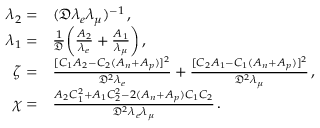Convert formula to latex. <formula><loc_0><loc_0><loc_500><loc_500>\begin{array} { r l } { \lambda _ { 2 } = } & { ( \mathfrak { D } \lambda _ { e } \lambda _ { \mu } ) ^ { - 1 } \, , } \\ { \lambda _ { 1 } = } & { \frac { 1 } { \mathfrak { D } } \left ( \frac { A _ { 2 } } { \lambda _ { e } } + \frac { A _ { 1 } } { \lambda _ { \mu } } \right ) \, , } \\ { \zeta = } & { \frac { [ C _ { 1 } A _ { 2 } - C _ { 2 } ( A _ { n } + A _ { p } ) ] ^ { 2 } } { \mathfrak { D } ^ { 2 } \lambda _ { e } } + \frac { [ C _ { 2 } A _ { 1 } - C _ { 1 } ( A _ { n } + A _ { p } ) ] ^ { 2 } } { \mathfrak { D } ^ { 2 } \lambda _ { \mu } } \, , } \\ { \chi = } & { \frac { A _ { 2 } C _ { 1 } ^ { 2 } + A _ { 1 } C _ { 2 } ^ { 2 } - 2 ( A _ { n } + A _ { p } ) C _ { 1 } C _ { 2 } } { \mathfrak { D } ^ { 2 } \lambda _ { e } \lambda _ { \mu } } \, . } \end{array}</formula> 